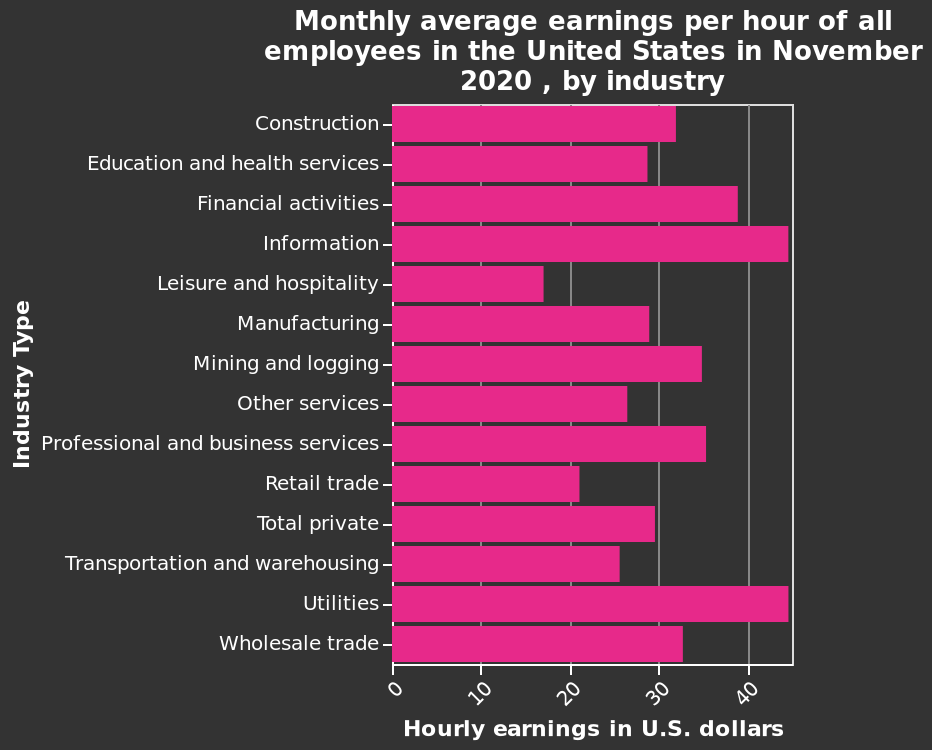<image>
What does the y-axis measure in the bar diagram? The y-axis measures industry type using a categorical scale starting with Construction and ending with Wholesale trade. Which industry type has the highest monthly average earnings per hour in the United States in November 2020? The bar diagram does not provide specific data points for industries, so it cannot be determined which industry had the highest monthly average earnings per hour based solely on the diagram. What does the x-axis measure in the bar diagram? The x-axis measures hourly earnings in U.S. dollars using a linear scale with a minimum of 0 and a maximum of 40. What is the time frame of the data represented in the bar diagram? The data is for the month of November 2020. Does the x-axis measure hourly earnings in Canadian dollars using a logarithmic scale with a minimum of -10 and a maximum of 100? No.The x-axis measures hourly earnings in U.S. dollars using a linear scale with a minimum of 0 and a maximum of 40. 